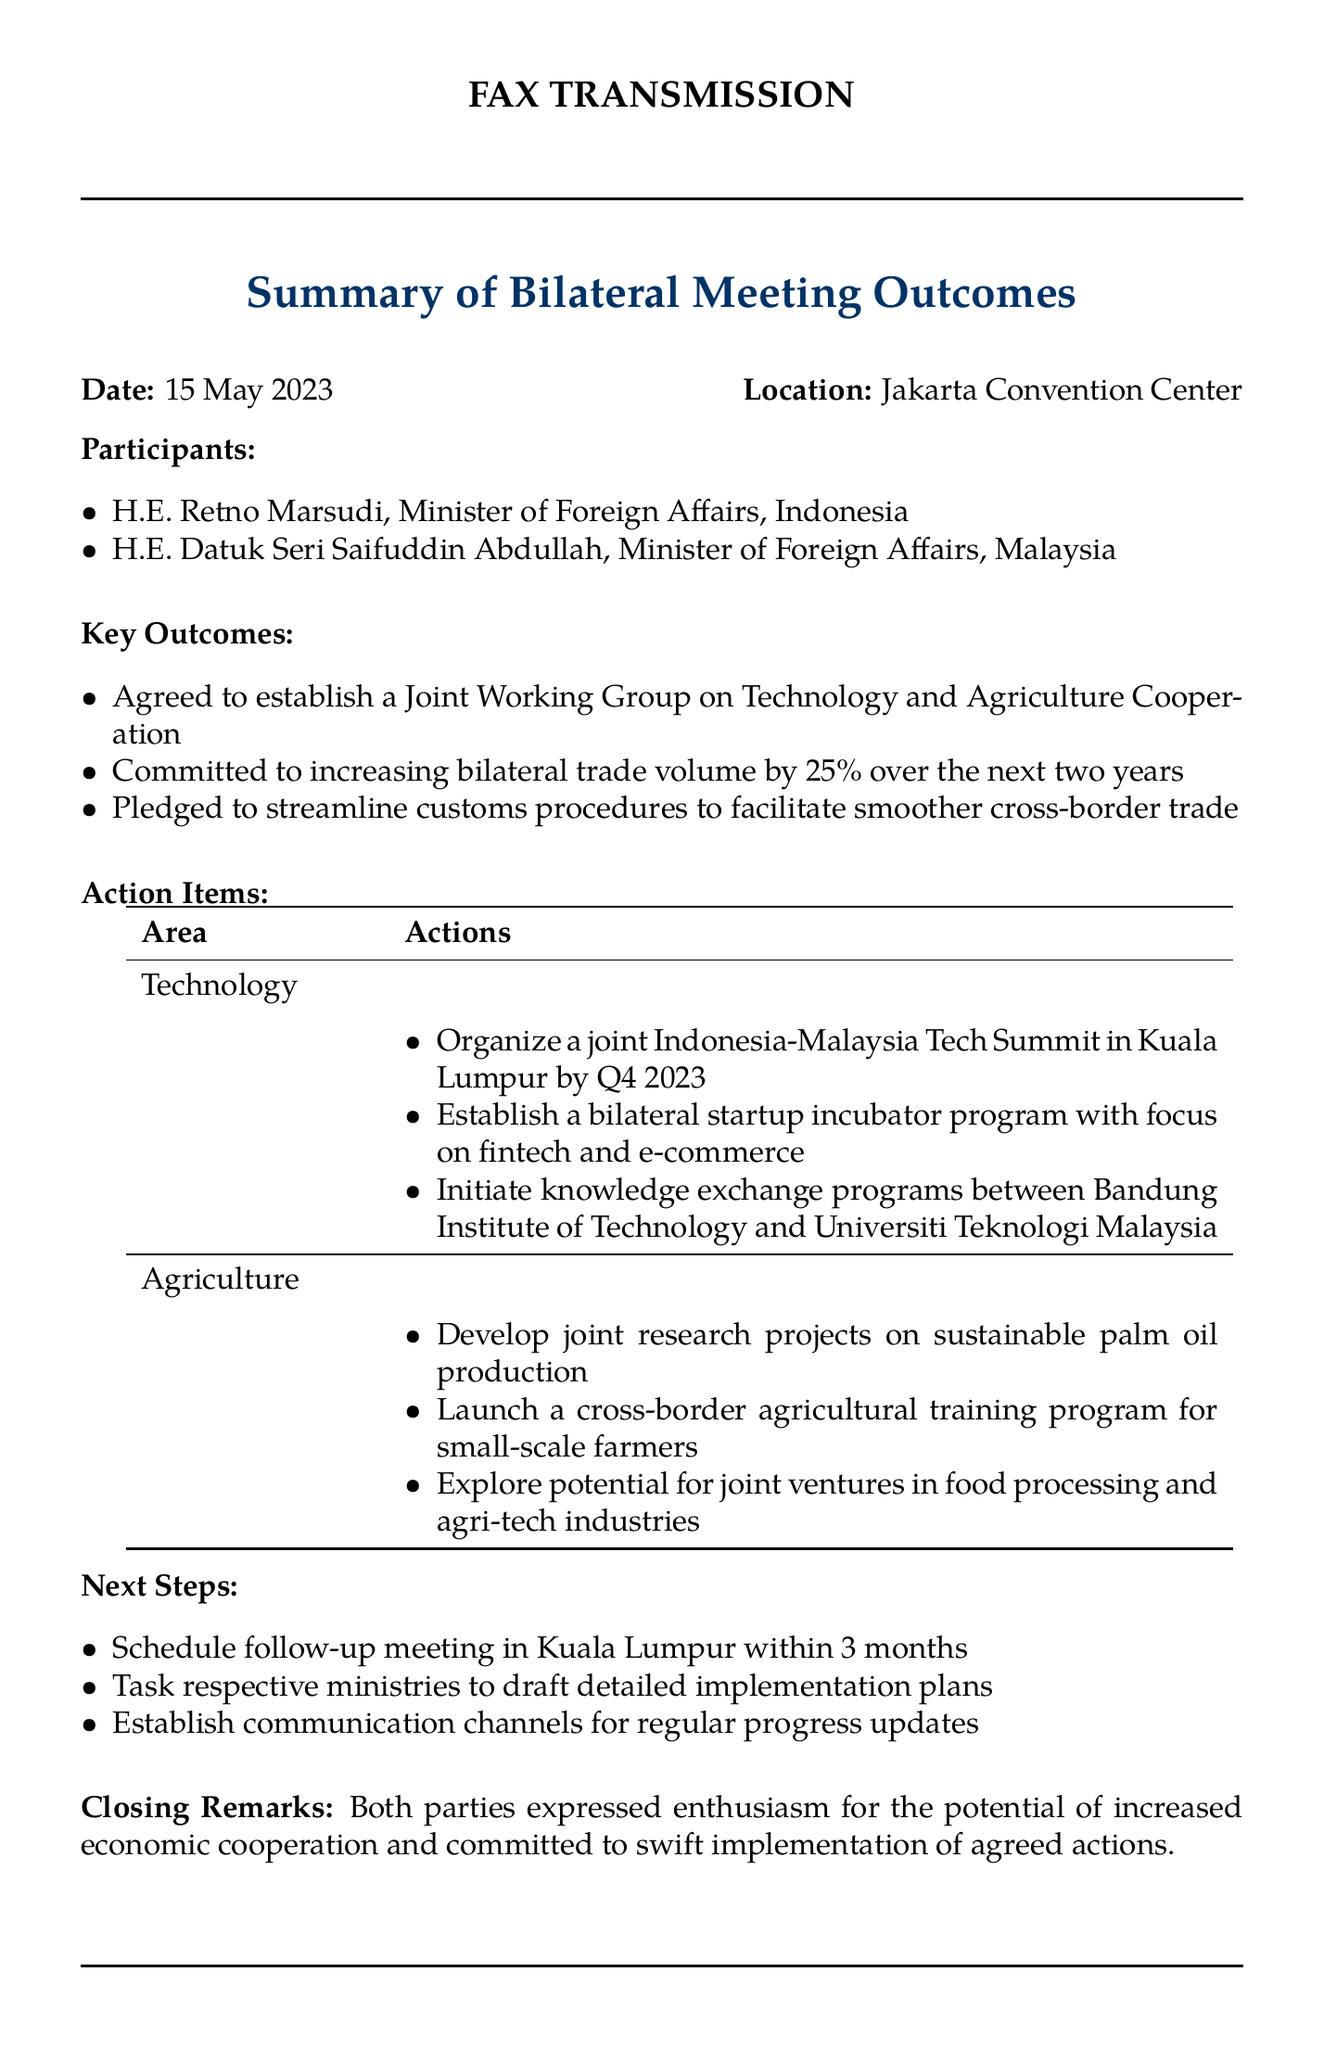What date was the bilateral meeting held? The date of the bilateral meeting is explicitly stated in the document as 15 May 2023.
Answer: 15 May 2023 Who is the Minister of Foreign Affairs for Malaysia? The document lists H.E. Datuk Seri Saifuddin Abdullah as the Minister of Foreign Affairs for Malaysia.
Answer: H.E. Datuk Seri Saifuddin Abdullah What is the target increase in bilateral trade volume? The document mentions a commitment to increase bilateral trade volume by 25% over the next two years.
Answer: 25% What is one action item under Technology? The document lists several actions under Technology, one of which is to organize a joint Indonesia-Malaysia Tech Summit in Kuala Lumpur by Q4 2023.
Answer: Organize a joint Indonesia-Malaysia Tech Summit in Kuala Lumpur by Q4 2023 What type of joint research projects are to be developed? The document specifies that joint research projects on sustainable palm oil production are to be developed.
Answer: Sustainable palm oil production When is the follow-up meeting scheduled to take place? The document states that a follow-up meeting should be scheduled in Kuala Lumpur within 3 months.
Answer: Within 3 months What is the main purpose of the Joint Working Group established? The document indicates that the Joint Working Group is focused on Technology and Agriculture Cooperation.
Answer: Technology and Agriculture Cooperation What is one area of focus for the bilateral startup incubator program? The document mentions that the bilateral startup incubator program will focus on fintech and e-commerce.
Answer: Fintech and e-commerce 